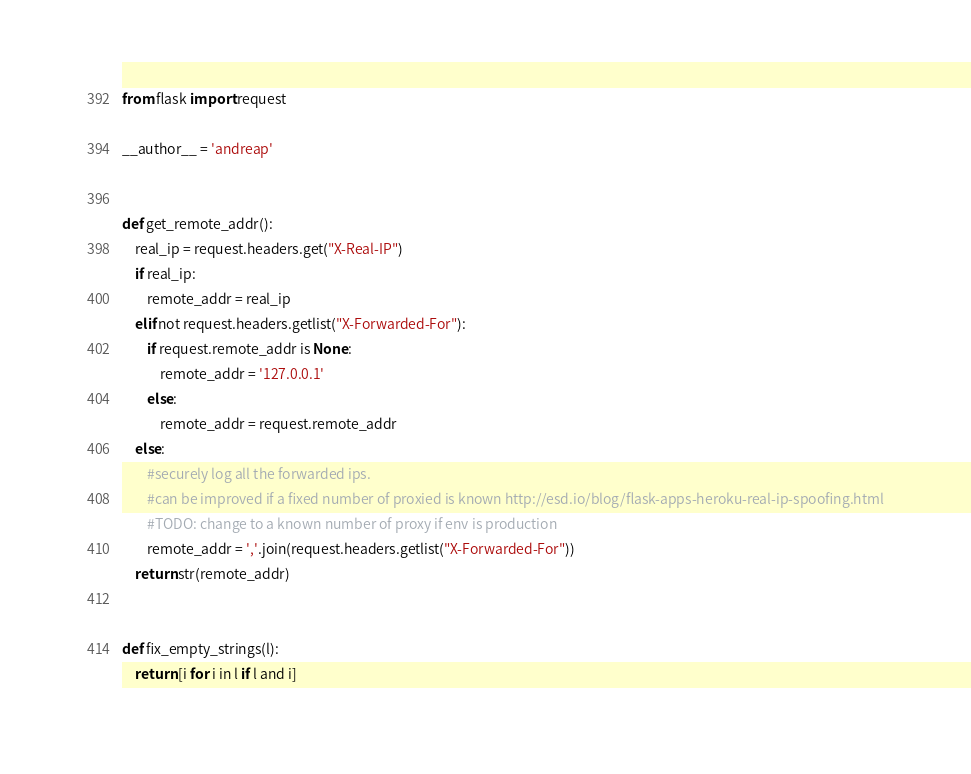<code> <loc_0><loc_0><loc_500><loc_500><_Python_>from flask import request

__author__ = 'andreap'


def get_remote_addr():
    real_ip = request.headers.get("X-Real-IP")
    if real_ip:
        remote_addr = real_ip
    elif not request.headers.getlist("X-Forwarded-For"):
        if request.remote_addr is None:
            remote_addr = '127.0.0.1'
        else:
            remote_addr = request.remote_addr
    else:
        #securely log all the forwarded ips.
        #can be improved if a fixed number of proxied is known http://esd.io/blog/flask-apps-heroku-real-ip-spoofing.html
        #TODO: change to a known number of proxy if env is production
        remote_addr = ','.join(request.headers.getlist("X-Forwarded-For"))
    return str(remote_addr)


def fix_empty_strings(l):
    return [i for i in l if l and i]
</code> 